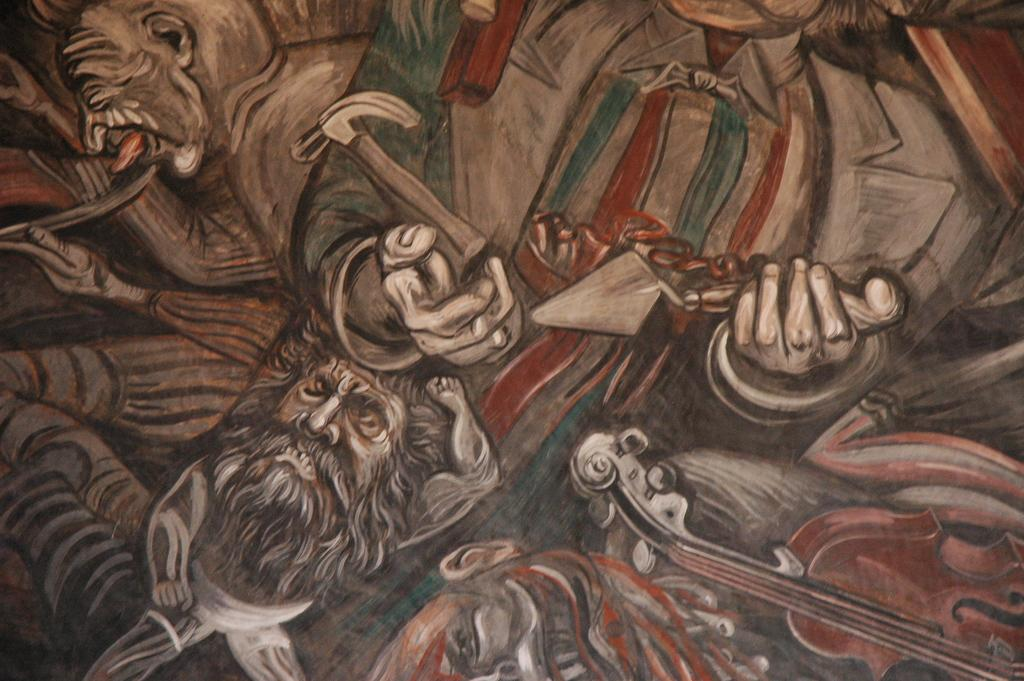How many people are in the image? There are persons in the image, but the exact number is not specified. What are the persons in the image doing? The persons in the image are holding objects. How many times does the person with the red nose sneeze in the image? There is no mention of a person with a red nose or sneezing in the image, so this question cannot be answered. 